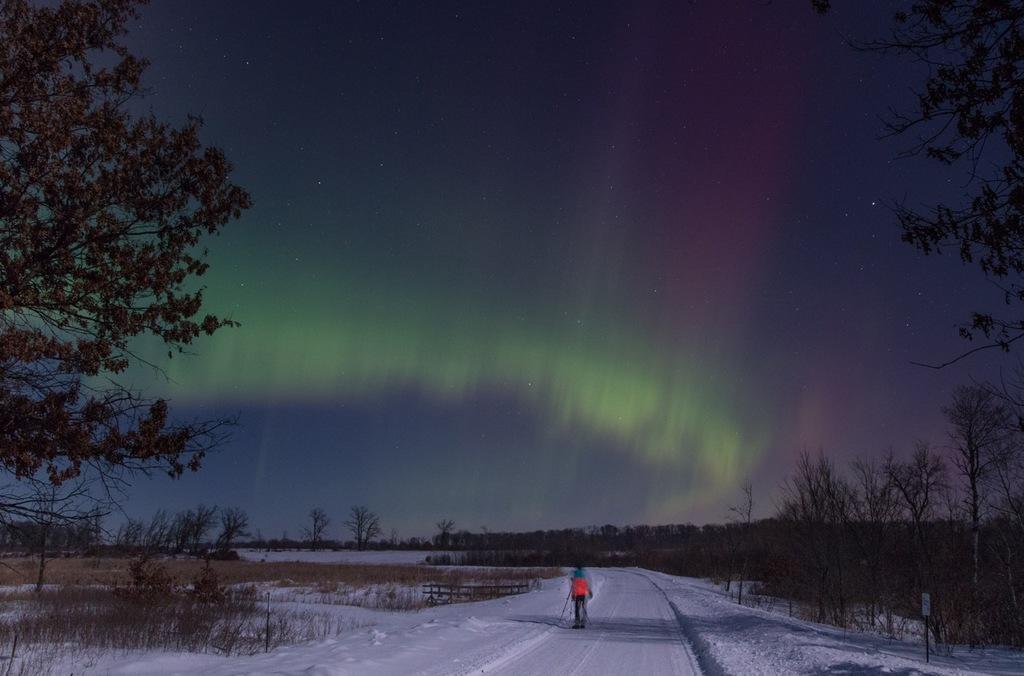Can you describe this image briefly? In this picture, we can see a person, and we can see the ground with snow, trees, plants, and the sky. 